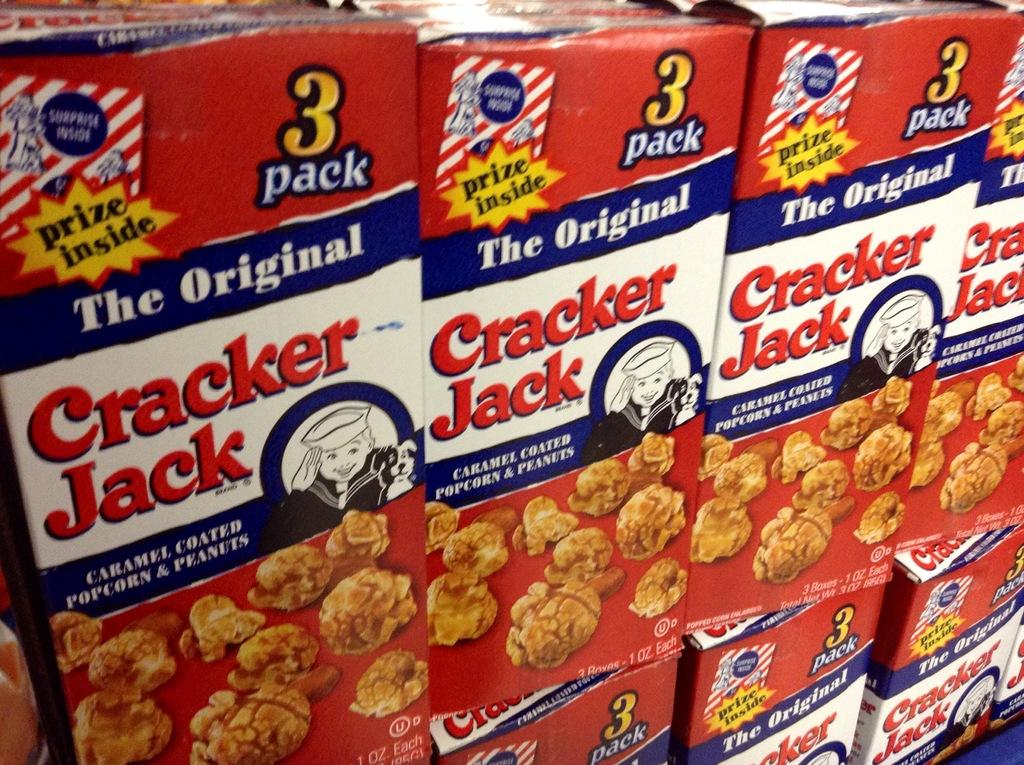What is the main subject of the image? The main subject of the image is many food boxes. What can be found on the food boxes? The food boxes have labels. What information is included on the labels? The labels contain text and images. What type of scent can be detected from the food boxes in the image? There is no indication of scent in the image, as it only shows food boxes with labels containing text and images. 